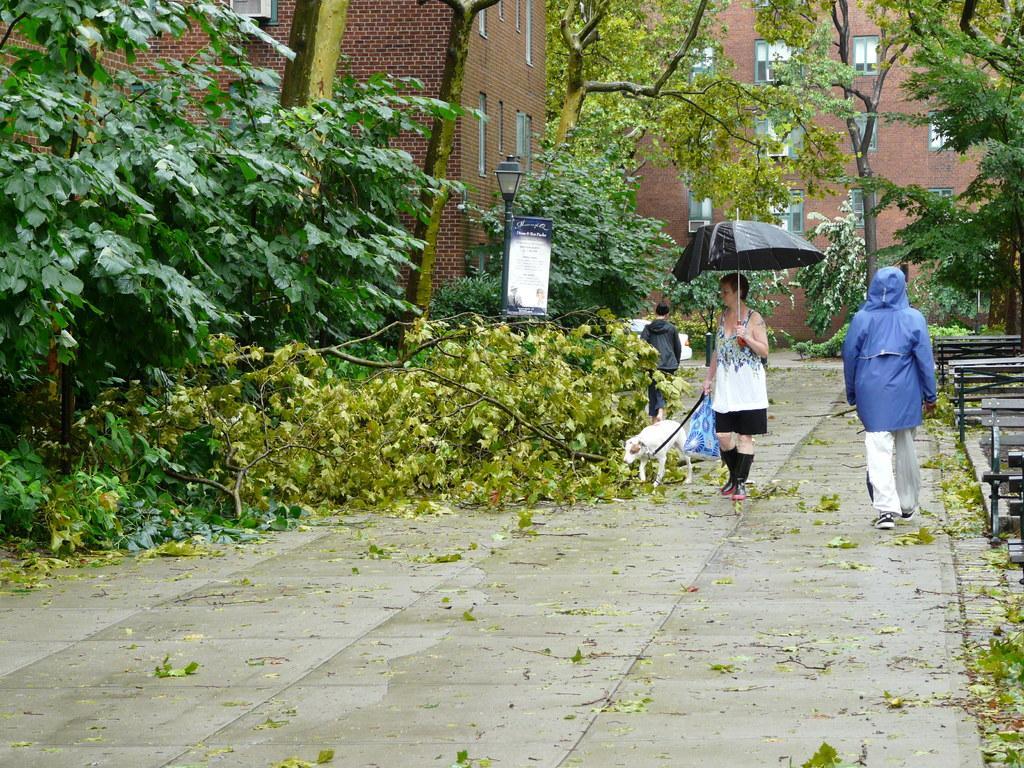Describe this image in one or two sentences. In this image there are trees and buildings in the left corner. There are benches and trees in the right corner. There is a road at the bottom. There are people in the foreground. And there are trees and buildings in the background. 